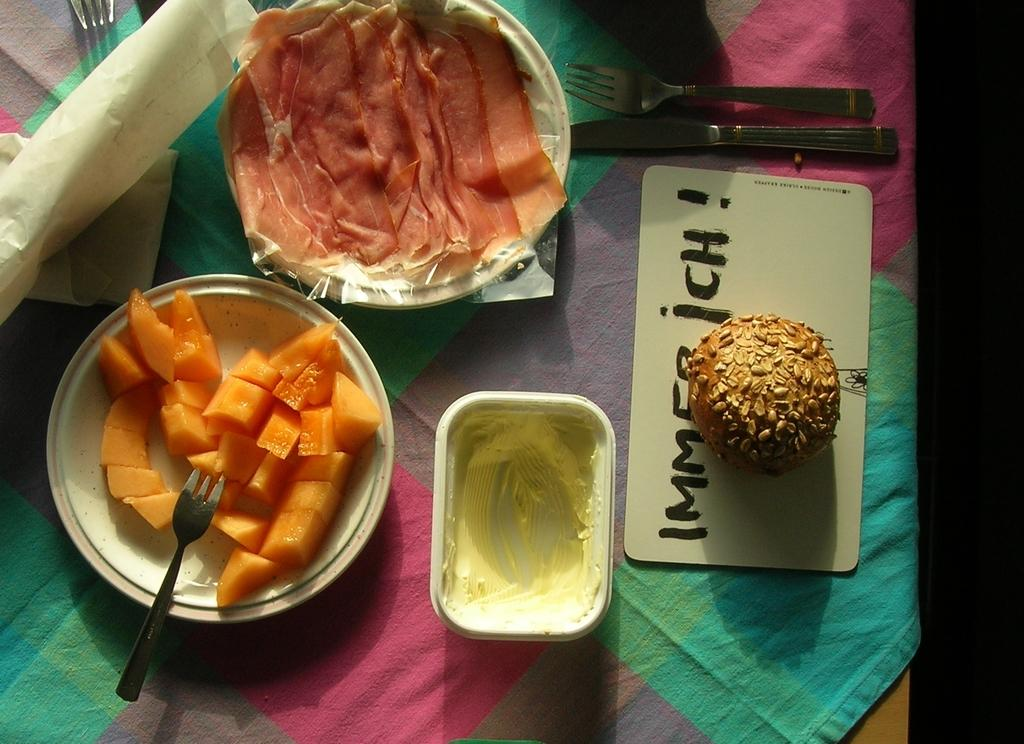What type of food items can be seen on the plates in the image? The specific food items are not mentioned, but there are plates with food items in the image. What utensils are present in the image? There are forks and knives in the image. What type of containers are present in the image? There are bowls in the image. What other objects can be seen in the image? There are papers and a cloth in the image. Where are all these objects placed? All of these objects are placed on a table. What type of question is being asked on the stamp in the image? There is no stamp present in the image, so this question cannot be answered. 